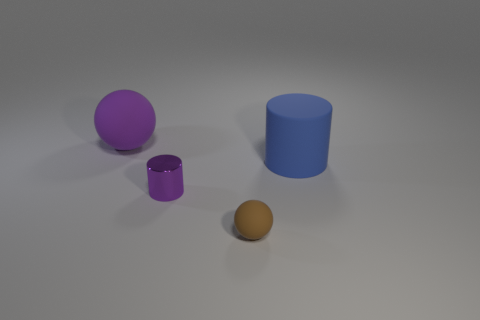Add 1 blue rubber cylinders. How many objects exist? 5 Add 4 blue objects. How many blue objects exist? 5 Subtract 1 brown balls. How many objects are left? 3 Subtract all large cyan cylinders. Subtract all purple spheres. How many objects are left? 3 Add 3 small objects. How many small objects are left? 5 